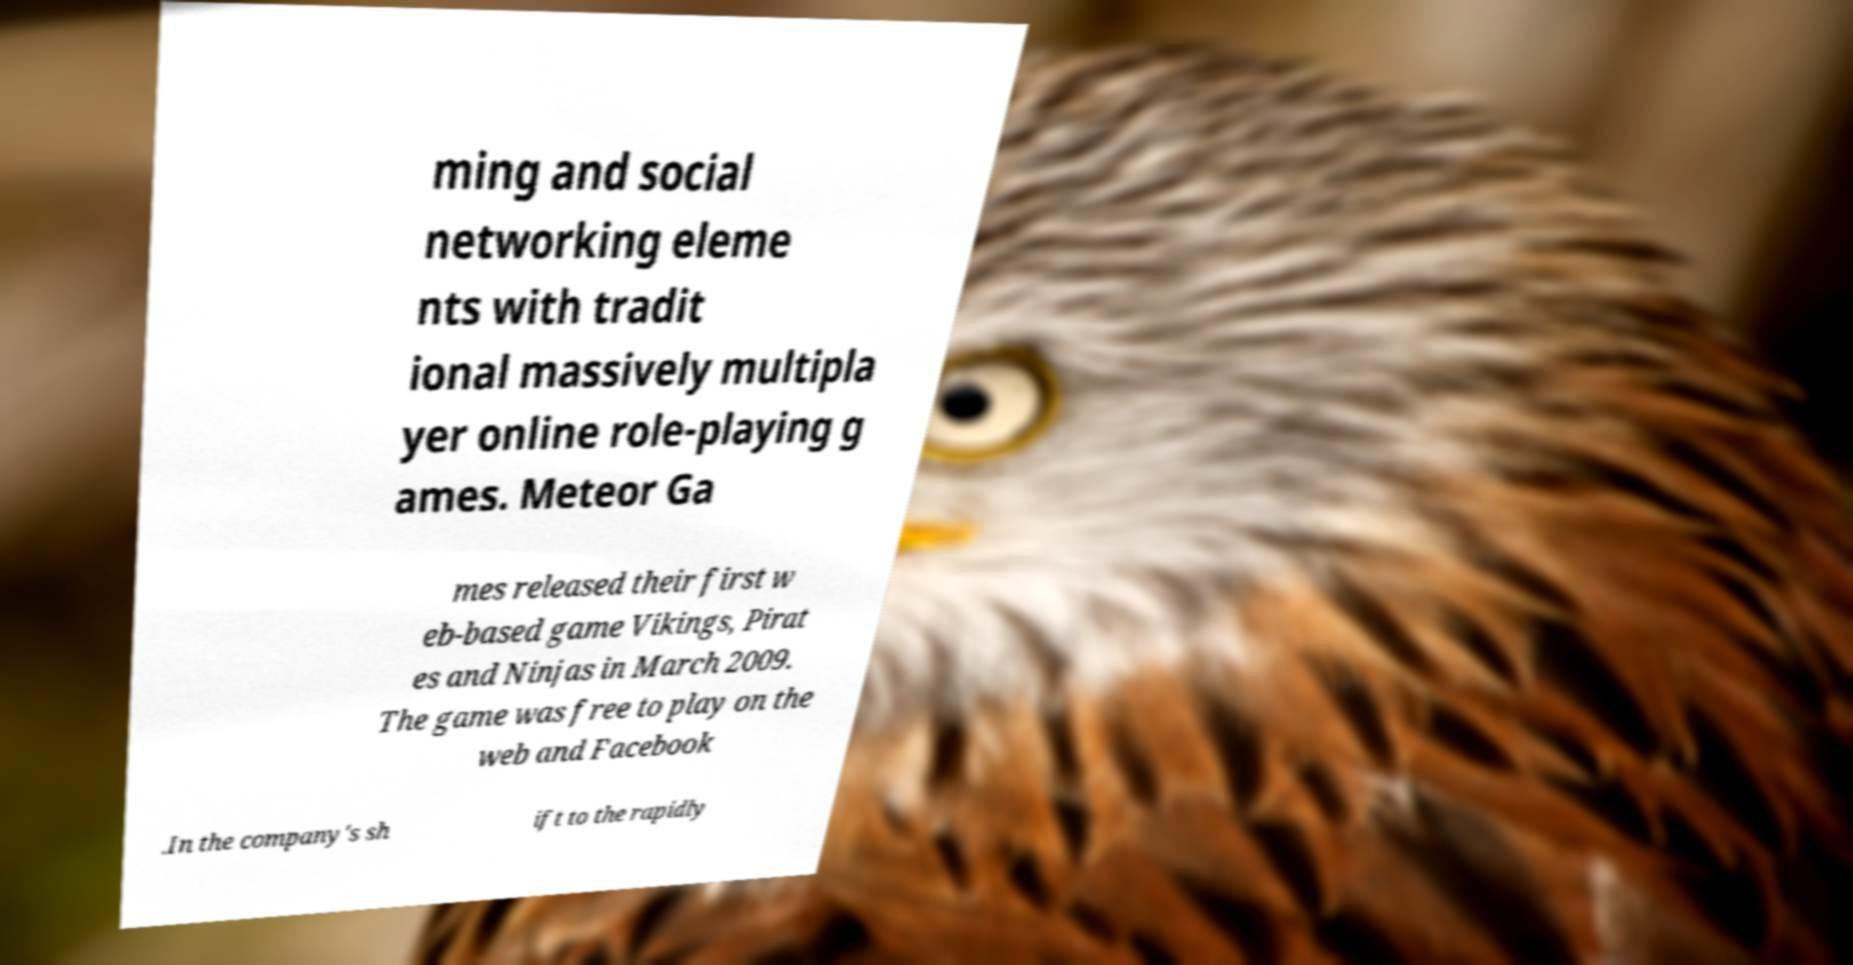For documentation purposes, I need the text within this image transcribed. Could you provide that? ming and social networking eleme nts with tradit ional massively multipla yer online role-playing g ames. Meteor Ga mes released their first w eb-based game Vikings, Pirat es and Ninjas in March 2009. The game was free to play on the web and Facebook .In the company's sh ift to the rapidly 